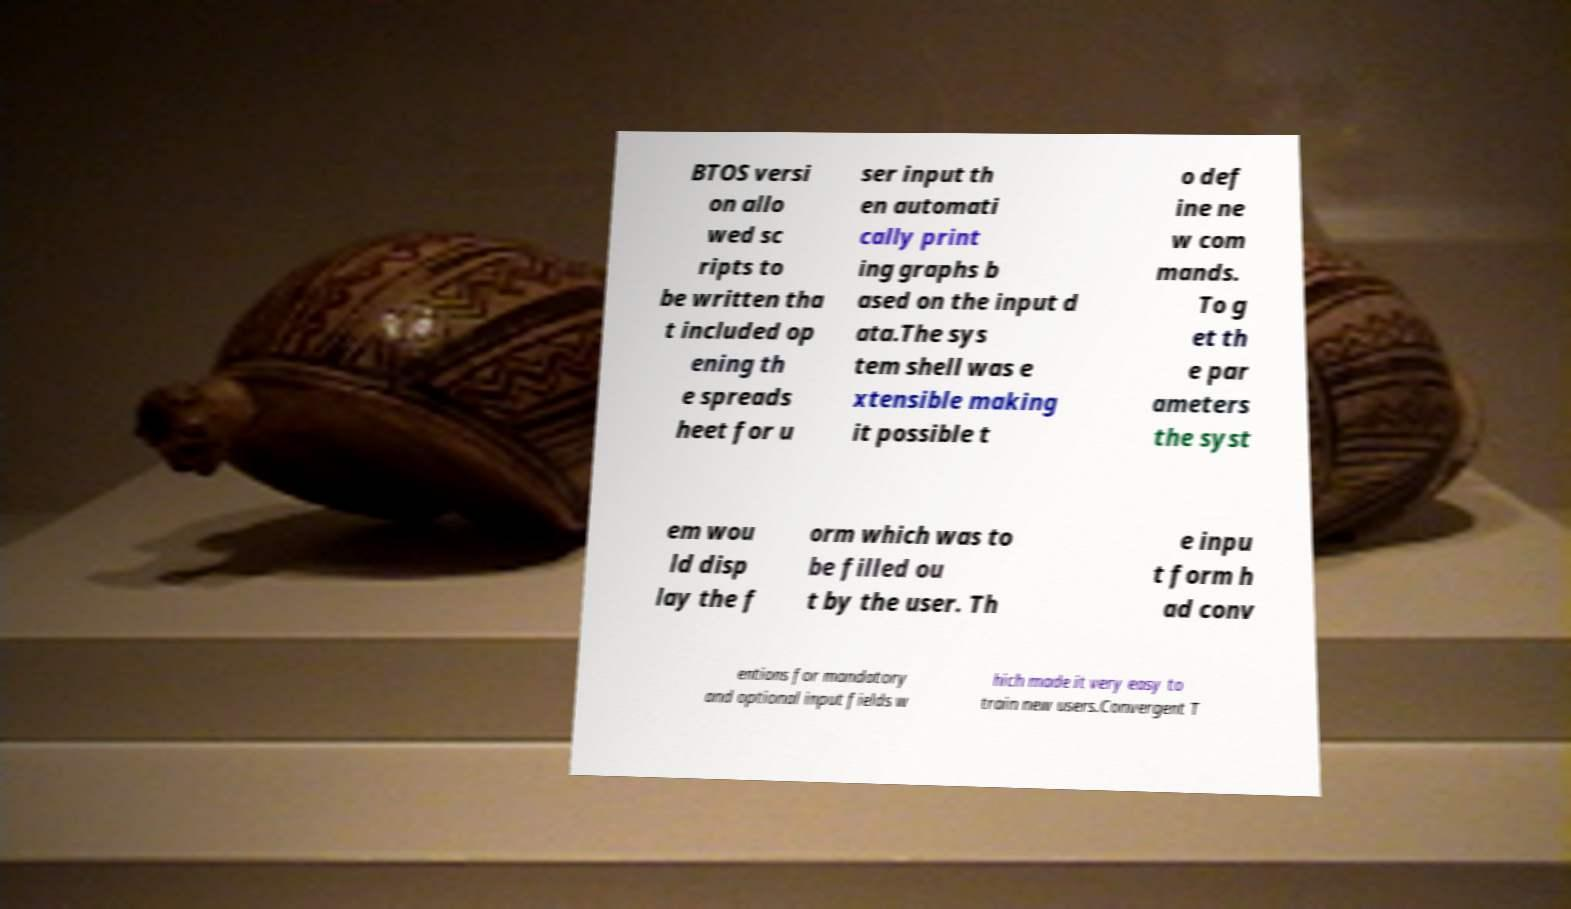Please identify and transcribe the text found in this image. BTOS versi on allo wed sc ripts to be written tha t included op ening th e spreads heet for u ser input th en automati cally print ing graphs b ased on the input d ata.The sys tem shell was e xtensible making it possible t o def ine ne w com mands. To g et th e par ameters the syst em wou ld disp lay the f orm which was to be filled ou t by the user. Th e inpu t form h ad conv entions for mandatory and optional input fields w hich made it very easy to train new users.Convergent T 